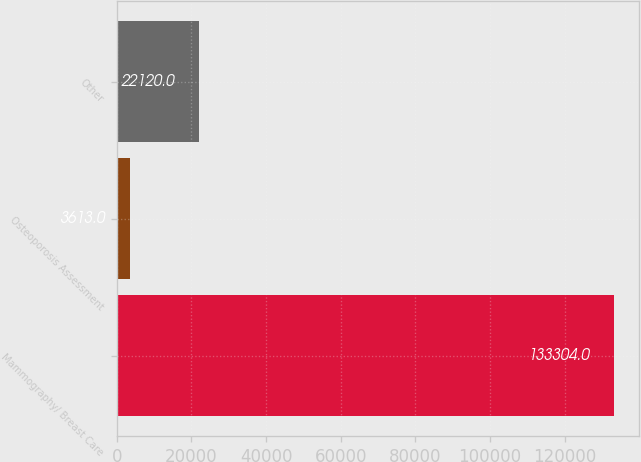<chart> <loc_0><loc_0><loc_500><loc_500><bar_chart><fcel>Mammography/ Breast Care<fcel>Osteoporosis Assessment<fcel>Other<nl><fcel>133304<fcel>3613<fcel>22120<nl></chart> 